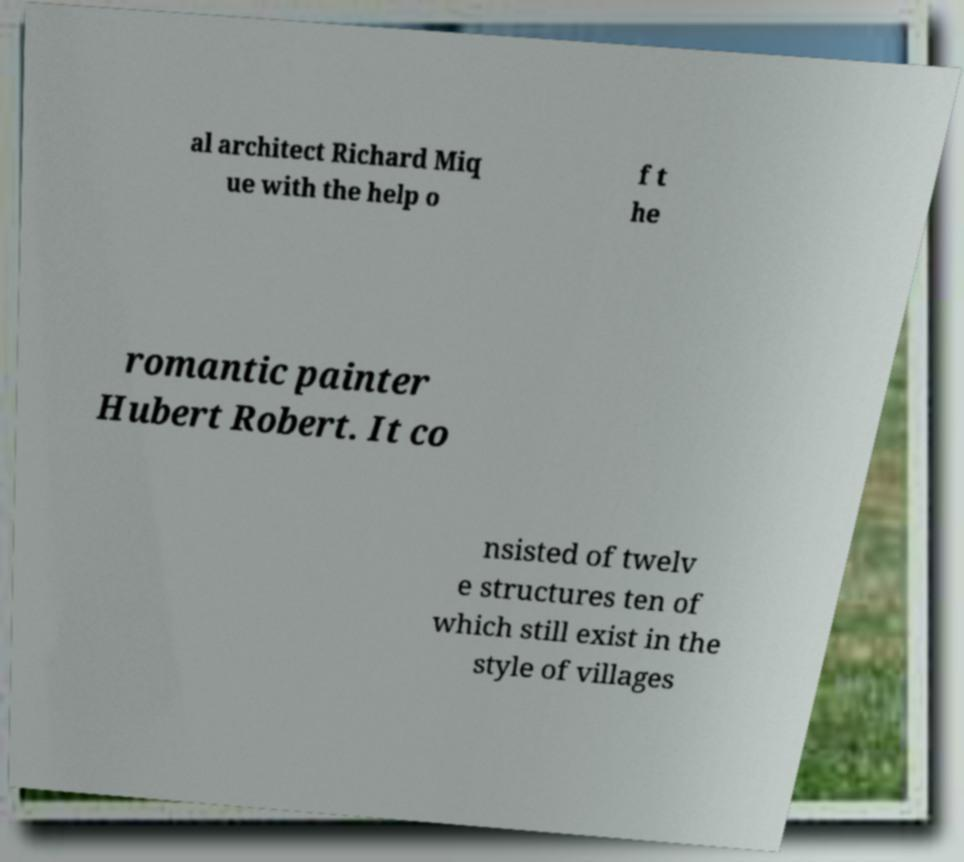I need the written content from this picture converted into text. Can you do that? al architect Richard Miq ue with the help o f t he romantic painter Hubert Robert. It co nsisted of twelv e structures ten of which still exist in the style of villages 